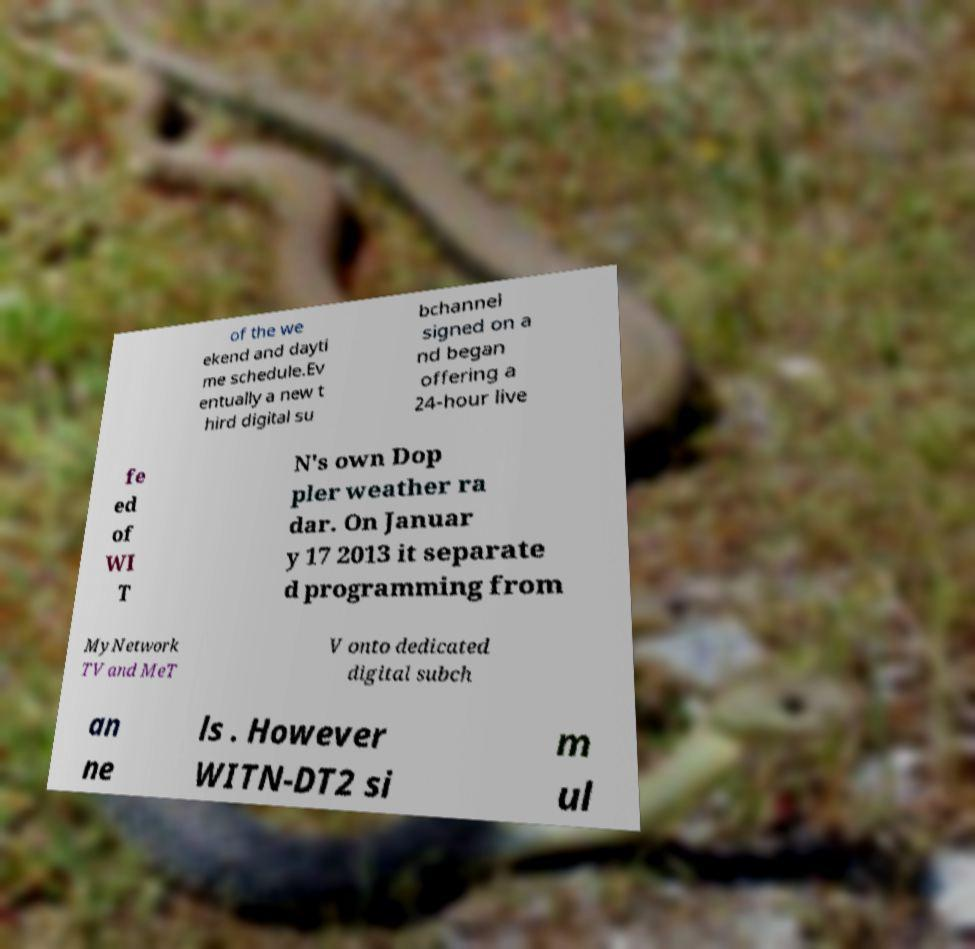Please identify and transcribe the text found in this image. of the we ekend and dayti me schedule.Ev entually a new t hird digital su bchannel signed on a nd began offering a 24-hour live fe ed of WI T N's own Dop pler weather ra dar. On Januar y 17 2013 it separate d programming from MyNetwork TV and MeT V onto dedicated digital subch an ne ls . However WITN-DT2 si m ul 